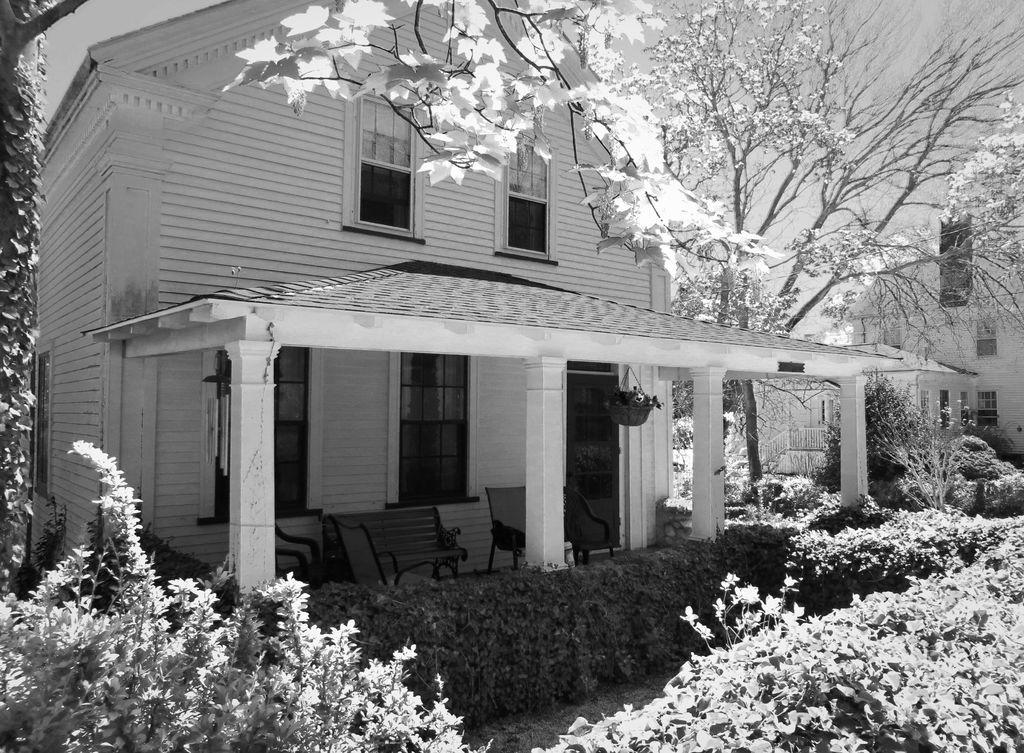What is the color scheme of the image? The image is black and white. What type of structure is present in the image? There is a house in the image. What type of furniture can be seen in the image? There are chairs in the image. What type of vegetation is at the bottom of the image? There are plants at the bottom of the image. What can be seen in the background of the image? There is a tree and the sky visible in the background of the image. How many clovers are growing in the image? There are no clovers present in the image. What is the name of the son in the image? There is no person or son mentioned in the image. 